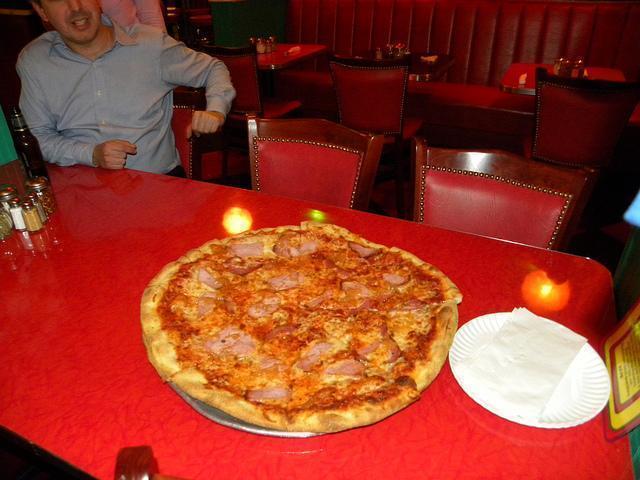What are the small candles on the table called?
Select the accurate answer and provide explanation: 'Answer: answer
Rationale: rationale.'
Options: Mini lights, table lights, tiny lights, tea lights. Answer: table lights.
Rationale: The candles are called tea lights. 